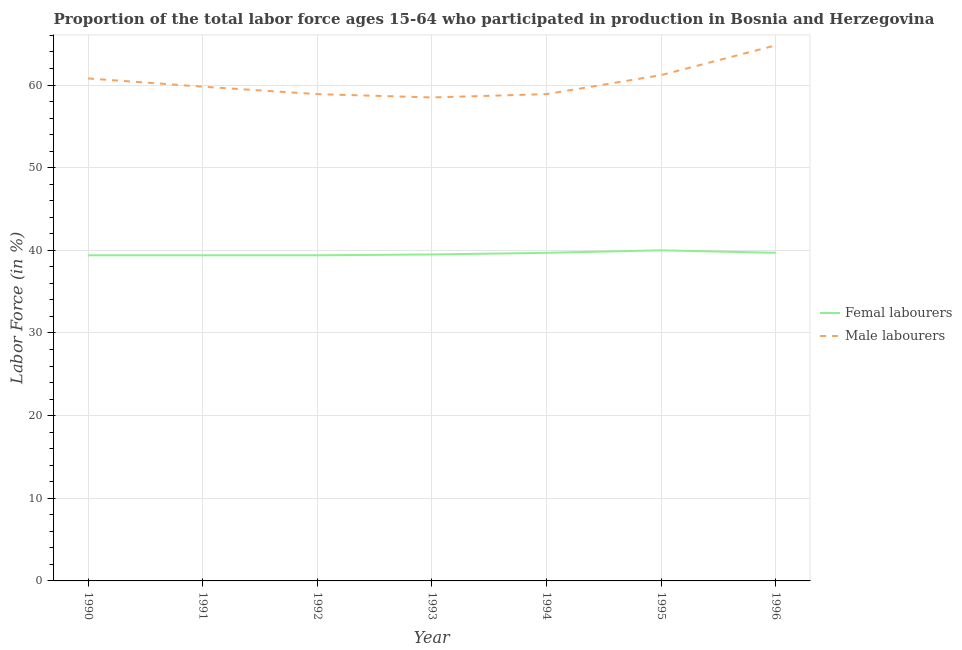How many different coloured lines are there?
Keep it short and to the point. 2. What is the percentage of male labour force in 1995?
Provide a succinct answer. 61.2. Across all years, what is the minimum percentage of male labour force?
Give a very brief answer. 58.5. In which year was the percentage of female labor force maximum?
Provide a succinct answer. 1995. In which year was the percentage of male labour force minimum?
Your response must be concise. 1993. What is the total percentage of female labor force in the graph?
Offer a terse response. 277.1. What is the difference between the percentage of male labour force in 1992 and that in 1996?
Ensure brevity in your answer.  -5.9. What is the difference between the percentage of female labor force in 1992 and the percentage of male labour force in 1990?
Offer a terse response. -21.4. What is the average percentage of male labour force per year?
Provide a short and direct response. 60.41. In the year 1991, what is the difference between the percentage of female labor force and percentage of male labour force?
Your response must be concise. -20.4. In how many years, is the percentage of male labour force greater than 46 %?
Offer a terse response. 7. What is the ratio of the percentage of male labour force in 1990 to that in 1992?
Your answer should be very brief. 1.03. Is the percentage of female labor force in 1995 less than that in 1996?
Your answer should be compact. No. What is the difference between the highest and the second highest percentage of male labour force?
Make the answer very short. 3.6. What is the difference between the highest and the lowest percentage of male labour force?
Your response must be concise. 6.3. Is the sum of the percentage of female labor force in 1990 and 1993 greater than the maximum percentage of male labour force across all years?
Offer a terse response. Yes. What is the difference between two consecutive major ticks on the Y-axis?
Make the answer very short. 10. Does the graph contain any zero values?
Your answer should be compact. No. Where does the legend appear in the graph?
Your response must be concise. Center right. How many legend labels are there?
Ensure brevity in your answer.  2. How are the legend labels stacked?
Provide a short and direct response. Vertical. What is the title of the graph?
Your answer should be very brief. Proportion of the total labor force ages 15-64 who participated in production in Bosnia and Herzegovina. What is the label or title of the Y-axis?
Offer a very short reply. Labor Force (in %). What is the Labor Force (in %) of Femal labourers in 1990?
Make the answer very short. 39.4. What is the Labor Force (in %) in Male labourers in 1990?
Provide a succinct answer. 60.8. What is the Labor Force (in %) of Femal labourers in 1991?
Your answer should be compact. 39.4. What is the Labor Force (in %) of Male labourers in 1991?
Your response must be concise. 59.8. What is the Labor Force (in %) in Femal labourers in 1992?
Your answer should be compact. 39.4. What is the Labor Force (in %) in Male labourers in 1992?
Provide a succinct answer. 58.9. What is the Labor Force (in %) of Femal labourers in 1993?
Offer a very short reply. 39.5. What is the Labor Force (in %) of Male labourers in 1993?
Keep it short and to the point. 58.5. What is the Labor Force (in %) in Femal labourers in 1994?
Offer a very short reply. 39.7. What is the Labor Force (in %) in Male labourers in 1994?
Keep it short and to the point. 58.9. What is the Labor Force (in %) of Male labourers in 1995?
Make the answer very short. 61.2. What is the Labor Force (in %) in Femal labourers in 1996?
Give a very brief answer. 39.7. What is the Labor Force (in %) of Male labourers in 1996?
Ensure brevity in your answer.  64.8. Across all years, what is the maximum Labor Force (in %) in Male labourers?
Your answer should be compact. 64.8. Across all years, what is the minimum Labor Force (in %) of Femal labourers?
Your answer should be very brief. 39.4. Across all years, what is the minimum Labor Force (in %) of Male labourers?
Offer a very short reply. 58.5. What is the total Labor Force (in %) in Femal labourers in the graph?
Offer a terse response. 277.1. What is the total Labor Force (in %) of Male labourers in the graph?
Keep it short and to the point. 422.9. What is the difference between the Labor Force (in %) in Femal labourers in 1990 and that in 1993?
Provide a succinct answer. -0.1. What is the difference between the Labor Force (in %) in Male labourers in 1990 and that in 1993?
Your response must be concise. 2.3. What is the difference between the Labor Force (in %) in Femal labourers in 1990 and that in 1994?
Your response must be concise. -0.3. What is the difference between the Labor Force (in %) of Male labourers in 1990 and that in 1994?
Offer a terse response. 1.9. What is the difference between the Labor Force (in %) of Femal labourers in 1990 and that in 1995?
Keep it short and to the point. -0.6. What is the difference between the Labor Force (in %) of Femal labourers in 1990 and that in 1996?
Give a very brief answer. -0.3. What is the difference between the Labor Force (in %) of Male labourers in 1990 and that in 1996?
Your response must be concise. -4. What is the difference between the Labor Force (in %) of Femal labourers in 1991 and that in 1992?
Keep it short and to the point. 0. What is the difference between the Labor Force (in %) of Male labourers in 1991 and that in 1993?
Your answer should be very brief. 1.3. What is the difference between the Labor Force (in %) in Femal labourers in 1991 and that in 1994?
Keep it short and to the point. -0.3. What is the difference between the Labor Force (in %) in Male labourers in 1991 and that in 1994?
Give a very brief answer. 0.9. What is the difference between the Labor Force (in %) in Femal labourers in 1991 and that in 1995?
Your answer should be very brief. -0.6. What is the difference between the Labor Force (in %) of Male labourers in 1991 and that in 1996?
Make the answer very short. -5. What is the difference between the Labor Force (in %) of Male labourers in 1992 and that in 1993?
Your response must be concise. 0.4. What is the difference between the Labor Force (in %) of Femal labourers in 1992 and that in 1995?
Make the answer very short. -0.6. What is the difference between the Labor Force (in %) of Femal labourers in 1992 and that in 1996?
Make the answer very short. -0.3. What is the difference between the Labor Force (in %) in Male labourers in 1992 and that in 1996?
Provide a short and direct response. -5.9. What is the difference between the Labor Force (in %) of Male labourers in 1993 and that in 1994?
Provide a succinct answer. -0.4. What is the difference between the Labor Force (in %) of Femal labourers in 1993 and that in 1995?
Give a very brief answer. -0.5. What is the difference between the Labor Force (in %) of Male labourers in 1993 and that in 1996?
Offer a very short reply. -6.3. What is the difference between the Labor Force (in %) of Femal labourers in 1994 and that in 1995?
Make the answer very short. -0.3. What is the difference between the Labor Force (in %) of Male labourers in 1994 and that in 1995?
Your answer should be very brief. -2.3. What is the difference between the Labor Force (in %) in Femal labourers in 1994 and that in 1996?
Make the answer very short. 0. What is the difference between the Labor Force (in %) in Femal labourers in 1995 and that in 1996?
Offer a very short reply. 0.3. What is the difference between the Labor Force (in %) in Male labourers in 1995 and that in 1996?
Your answer should be compact. -3.6. What is the difference between the Labor Force (in %) of Femal labourers in 1990 and the Labor Force (in %) of Male labourers in 1991?
Make the answer very short. -20.4. What is the difference between the Labor Force (in %) of Femal labourers in 1990 and the Labor Force (in %) of Male labourers in 1992?
Offer a very short reply. -19.5. What is the difference between the Labor Force (in %) in Femal labourers in 1990 and the Labor Force (in %) in Male labourers in 1993?
Ensure brevity in your answer.  -19.1. What is the difference between the Labor Force (in %) of Femal labourers in 1990 and the Labor Force (in %) of Male labourers in 1994?
Keep it short and to the point. -19.5. What is the difference between the Labor Force (in %) in Femal labourers in 1990 and the Labor Force (in %) in Male labourers in 1995?
Make the answer very short. -21.8. What is the difference between the Labor Force (in %) in Femal labourers in 1990 and the Labor Force (in %) in Male labourers in 1996?
Give a very brief answer. -25.4. What is the difference between the Labor Force (in %) of Femal labourers in 1991 and the Labor Force (in %) of Male labourers in 1992?
Provide a succinct answer. -19.5. What is the difference between the Labor Force (in %) in Femal labourers in 1991 and the Labor Force (in %) in Male labourers in 1993?
Offer a very short reply. -19.1. What is the difference between the Labor Force (in %) of Femal labourers in 1991 and the Labor Force (in %) of Male labourers in 1994?
Your answer should be very brief. -19.5. What is the difference between the Labor Force (in %) of Femal labourers in 1991 and the Labor Force (in %) of Male labourers in 1995?
Give a very brief answer. -21.8. What is the difference between the Labor Force (in %) of Femal labourers in 1991 and the Labor Force (in %) of Male labourers in 1996?
Keep it short and to the point. -25.4. What is the difference between the Labor Force (in %) in Femal labourers in 1992 and the Labor Force (in %) in Male labourers in 1993?
Make the answer very short. -19.1. What is the difference between the Labor Force (in %) of Femal labourers in 1992 and the Labor Force (in %) of Male labourers in 1994?
Give a very brief answer. -19.5. What is the difference between the Labor Force (in %) of Femal labourers in 1992 and the Labor Force (in %) of Male labourers in 1995?
Your answer should be compact. -21.8. What is the difference between the Labor Force (in %) of Femal labourers in 1992 and the Labor Force (in %) of Male labourers in 1996?
Make the answer very short. -25.4. What is the difference between the Labor Force (in %) in Femal labourers in 1993 and the Labor Force (in %) in Male labourers in 1994?
Your answer should be very brief. -19.4. What is the difference between the Labor Force (in %) of Femal labourers in 1993 and the Labor Force (in %) of Male labourers in 1995?
Your response must be concise. -21.7. What is the difference between the Labor Force (in %) of Femal labourers in 1993 and the Labor Force (in %) of Male labourers in 1996?
Your answer should be very brief. -25.3. What is the difference between the Labor Force (in %) of Femal labourers in 1994 and the Labor Force (in %) of Male labourers in 1995?
Offer a very short reply. -21.5. What is the difference between the Labor Force (in %) in Femal labourers in 1994 and the Labor Force (in %) in Male labourers in 1996?
Your answer should be very brief. -25.1. What is the difference between the Labor Force (in %) in Femal labourers in 1995 and the Labor Force (in %) in Male labourers in 1996?
Provide a succinct answer. -24.8. What is the average Labor Force (in %) of Femal labourers per year?
Provide a short and direct response. 39.59. What is the average Labor Force (in %) of Male labourers per year?
Your response must be concise. 60.41. In the year 1990, what is the difference between the Labor Force (in %) in Femal labourers and Labor Force (in %) in Male labourers?
Provide a succinct answer. -21.4. In the year 1991, what is the difference between the Labor Force (in %) of Femal labourers and Labor Force (in %) of Male labourers?
Your answer should be compact. -20.4. In the year 1992, what is the difference between the Labor Force (in %) in Femal labourers and Labor Force (in %) in Male labourers?
Provide a succinct answer. -19.5. In the year 1994, what is the difference between the Labor Force (in %) of Femal labourers and Labor Force (in %) of Male labourers?
Ensure brevity in your answer.  -19.2. In the year 1995, what is the difference between the Labor Force (in %) of Femal labourers and Labor Force (in %) of Male labourers?
Make the answer very short. -21.2. In the year 1996, what is the difference between the Labor Force (in %) in Femal labourers and Labor Force (in %) in Male labourers?
Provide a succinct answer. -25.1. What is the ratio of the Labor Force (in %) of Male labourers in 1990 to that in 1991?
Offer a terse response. 1.02. What is the ratio of the Labor Force (in %) of Femal labourers in 1990 to that in 1992?
Offer a terse response. 1. What is the ratio of the Labor Force (in %) in Male labourers in 1990 to that in 1992?
Your answer should be compact. 1.03. What is the ratio of the Labor Force (in %) of Femal labourers in 1990 to that in 1993?
Your answer should be very brief. 1. What is the ratio of the Labor Force (in %) of Male labourers in 1990 to that in 1993?
Offer a terse response. 1.04. What is the ratio of the Labor Force (in %) in Femal labourers in 1990 to that in 1994?
Your answer should be very brief. 0.99. What is the ratio of the Labor Force (in %) of Male labourers in 1990 to that in 1994?
Give a very brief answer. 1.03. What is the ratio of the Labor Force (in %) of Male labourers in 1990 to that in 1996?
Offer a terse response. 0.94. What is the ratio of the Labor Force (in %) in Male labourers in 1991 to that in 1992?
Give a very brief answer. 1.02. What is the ratio of the Labor Force (in %) of Male labourers in 1991 to that in 1993?
Offer a terse response. 1.02. What is the ratio of the Labor Force (in %) in Femal labourers in 1991 to that in 1994?
Provide a succinct answer. 0.99. What is the ratio of the Labor Force (in %) in Male labourers in 1991 to that in 1994?
Provide a succinct answer. 1.02. What is the ratio of the Labor Force (in %) in Femal labourers in 1991 to that in 1995?
Your response must be concise. 0.98. What is the ratio of the Labor Force (in %) of Male labourers in 1991 to that in 1995?
Provide a succinct answer. 0.98. What is the ratio of the Labor Force (in %) of Femal labourers in 1991 to that in 1996?
Ensure brevity in your answer.  0.99. What is the ratio of the Labor Force (in %) in Male labourers in 1991 to that in 1996?
Provide a succinct answer. 0.92. What is the ratio of the Labor Force (in %) in Male labourers in 1992 to that in 1993?
Your answer should be very brief. 1.01. What is the ratio of the Labor Force (in %) in Femal labourers in 1992 to that in 1994?
Keep it short and to the point. 0.99. What is the ratio of the Labor Force (in %) of Male labourers in 1992 to that in 1994?
Your response must be concise. 1. What is the ratio of the Labor Force (in %) in Male labourers in 1992 to that in 1995?
Your response must be concise. 0.96. What is the ratio of the Labor Force (in %) of Male labourers in 1992 to that in 1996?
Your response must be concise. 0.91. What is the ratio of the Labor Force (in %) in Male labourers in 1993 to that in 1994?
Make the answer very short. 0.99. What is the ratio of the Labor Force (in %) of Femal labourers in 1993 to that in 1995?
Provide a succinct answer. 0.99. What is the ratio of the Labor Force (in %) in Male labourers in 1993 to that in 1995?
Keep it short and to the point. 0.96. What is the ratio of the Labor Force (in %) of Femal labourers in 1993 to that in 1996?
Your answer should be compact. 0.99. What is the ratio of the Labor Force (in %) in Male labourers in 1993 to that in 1996?
Ensure brevity in your answer.  0.9. What is the ratio of the Labor Force (in %) of Male labourers in 1994 to that in 1995?
Ensure brevity in your answer.  0.96. What is the ratio of the Labor Force (in %) of Male labourers in 1994 to that in 1996?
Offer a terse response. 0.91. What is the ratio of the Labor Force (in %) of Femal labourers in 1995 to that in 1996?
Your response must be concise. 1.01. What is the difference between the highest and the lowest Labor Force (in %) in Male labourers?
Offer a terse response. 6.3. 